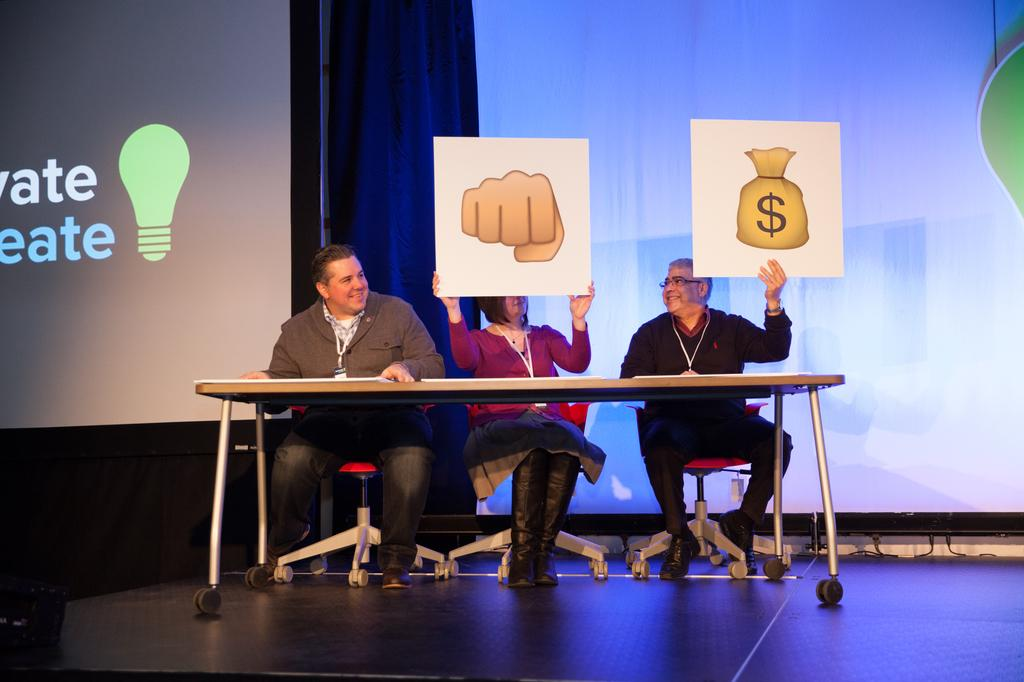How many people are sitting on chairs in the image? There are three people sitting on chairs in the image. What are two of the people holding? Two of the people are holding boards. What is in front of the three people? There is a table in front of the three people. What can be seen in the background of the image? There are screens and a curtain in the background. What type of town is visible in the background of the image? There is no town visible in the background of the image; it features screens and a curtain. How does the curtain twist in the image? The curtain does not twist in the image; it is stationary in the background. 